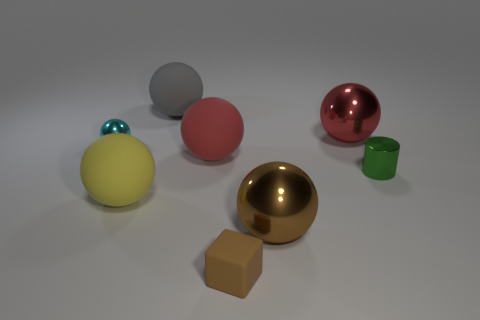How many objects are either metal spheres to the left of the brown metallic thing or brown rubber objects?
Your response must be concise. 2. How many small brown rubber objects are in front of the tiny shiny thing to the left of the large gray thing?
Provide a short and direct response. 1. Is the number of large red objects on the right side of the brown metallic sphere greater than the number of big purple rubber cubes?
Ensure brevity in your answer.  Yes. What is the size of the object that is on the left side of the brown metal ball and in front of the yellow rubber thing?
Keep it short and to the point. Small. There is a matte object that is both on the right side of the large gray object and in front of the tiny cylinder; what is its shape?
Offer a terse response. Cube. There is a thing that is in front of the shiny thing in front of the small green metal thing; are there any red balls that are to the right of it?
Provide a short and direct response. Yes. How many objects are big metallic things right of the large brown metal sphere or metal spheres that are left of the large gray matte sphere?
Keep it short and to the point. 2. Is the tiny thing behind the metallic cylinder made of the same material as the tiny brown cube?
Ensure brevity in your answer.  No. There is a thing that is on the left side of the gray matte sphere and in front of the cyan ball; what is its material?
Your answer should be compact. Rubber. What color is the metal ball that is in front of the thing that is left of the yellow rubber object?
Offer a terse response. Brown. 